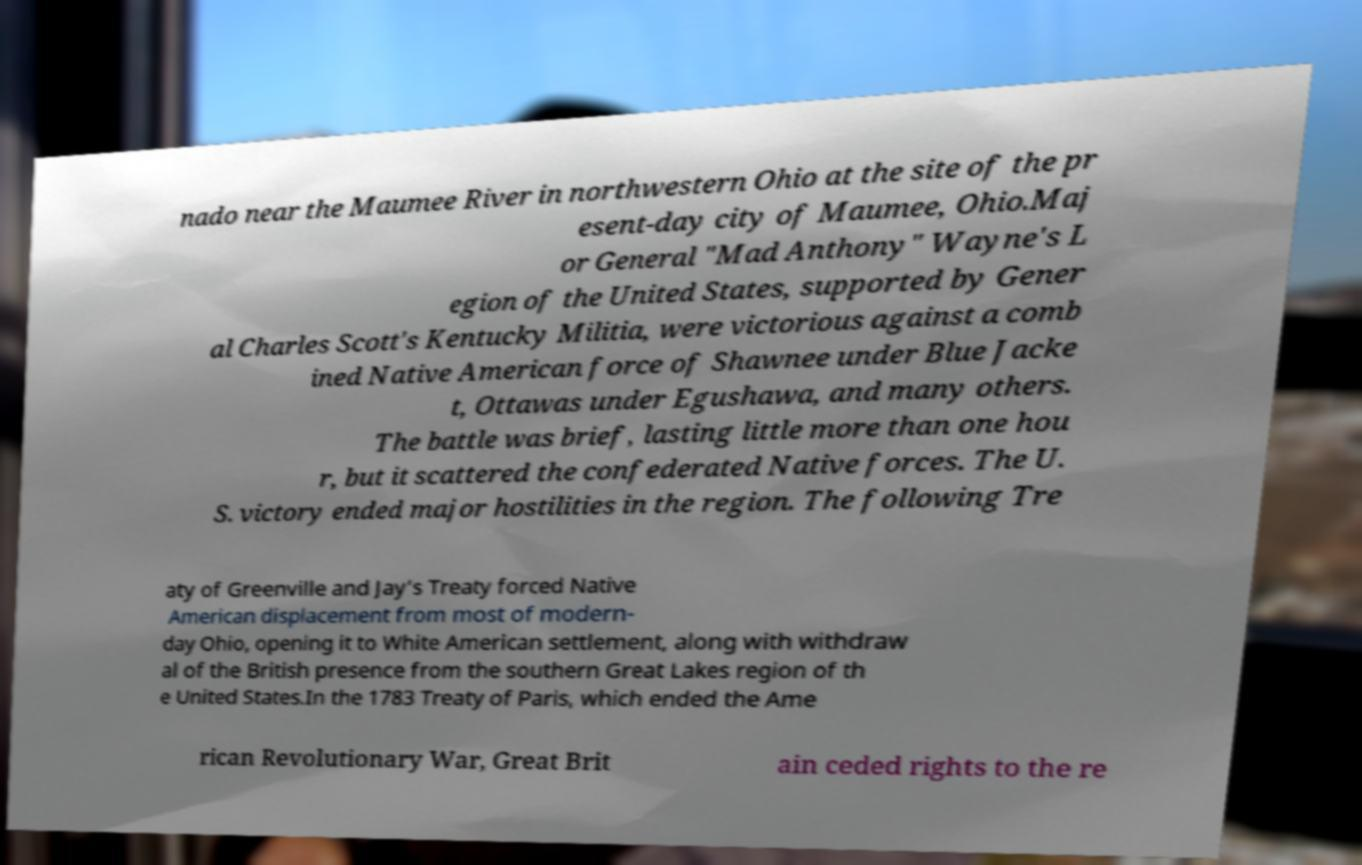What messages or text are displayed in this image? I need them in a readable, typed format. nado near the Maumee River in northwestern Ohio at the site of the pr esent-day city of Maumee, Ohio.Maj or General "Mad Anthony" Wayne's L egion of the United States, supported by Gener al Charles Scott's Kentucky Militia, were victorious against a comb ined Native American force of Shawnee under Blue Jacke t, Ottawas under Egushawa, and many others. The battle was brief, lasting little more than one hou r, but it scattered the confederated Native forces. The U. S. victory ended major hostilities in the region. The following Tre aty of Greenville and Jay's Treaty forced Native American displacement from most of modern- day Ohio, opening it to White American settlement, along with withdraw al of the British presence from the southern Great Lakes region of th e United States.In the 1783 Treaty of Paris, which ended the Ame rican Revolutionary War, Great Brit ain ceded rights to the re 